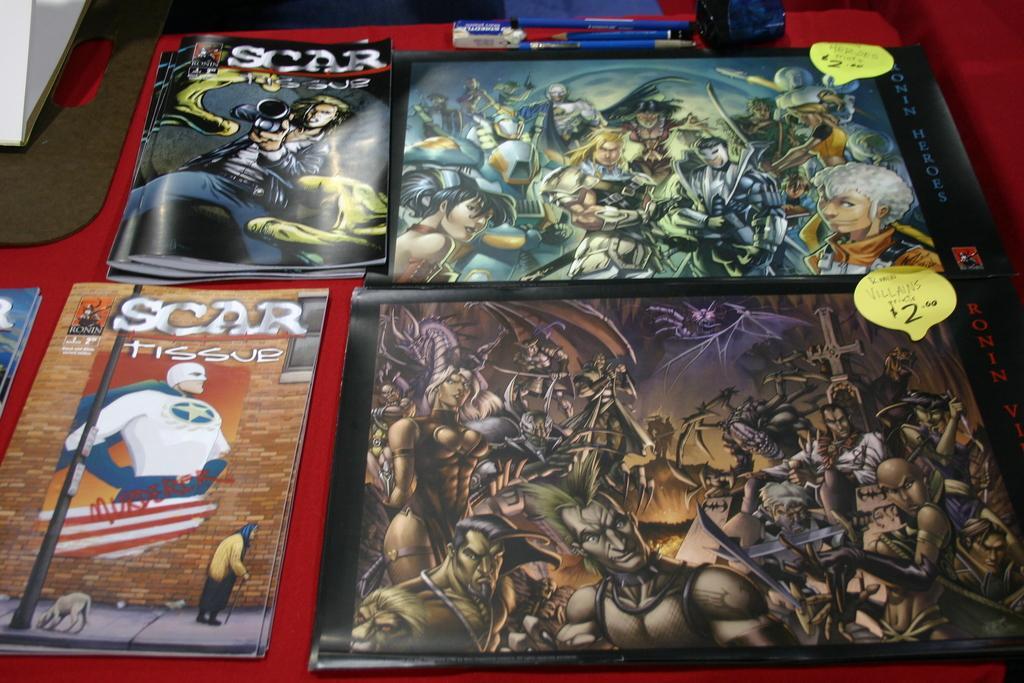In one or two sentences, can you explain what this image depicts? In this image there are pens, rubber, writing pad, some other objects and books with images and price tags on a table. 